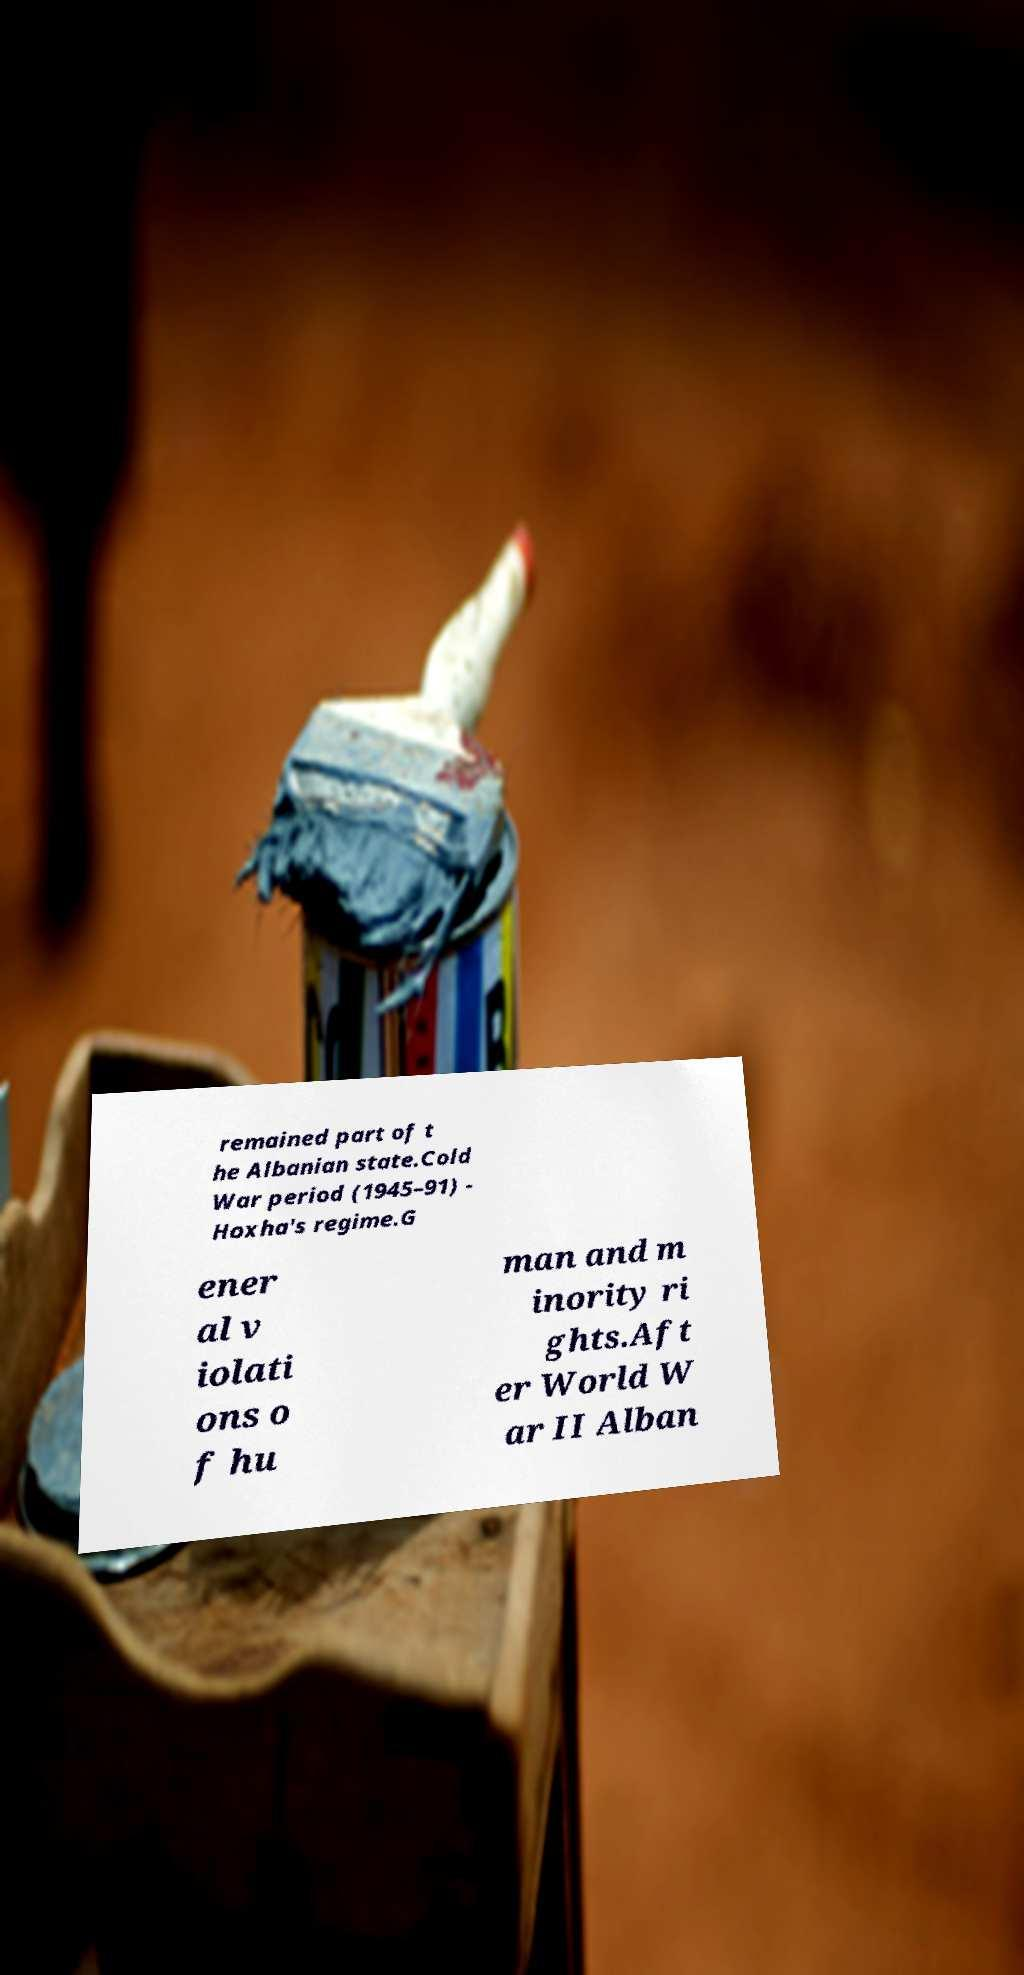Please identify and transcribe the text found in this image. remained part of t he Albanian state.Cold War period (1945–91) - Hoxha's regime.G ener al v iolati ons o f hu man and m inority ri ghts.Aft er World W ar II Alban 